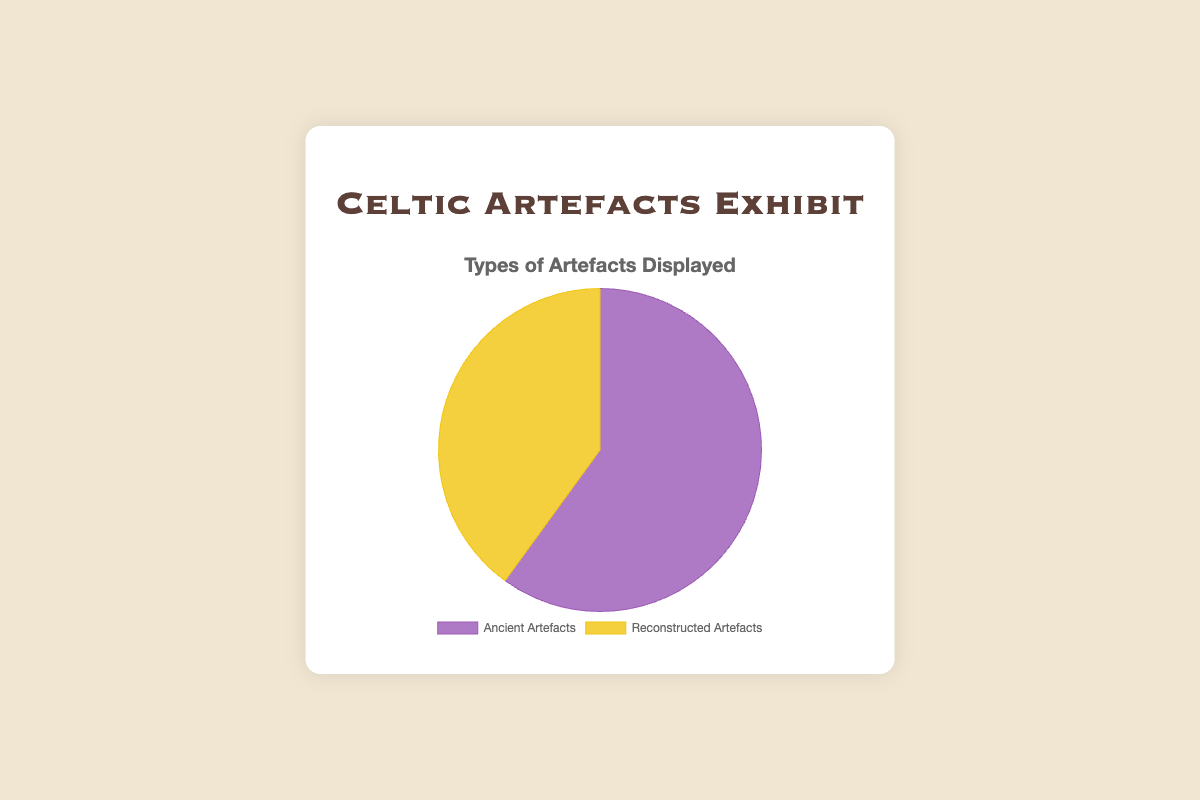What percentage of artefacts on display are ancient? To find the percentage of ancient artefacts, divide the number of ancient artefacts (60) by the total number of artefacts (60 + 40 = 100), then multiply by 100. (60/100) * 100 = 60%.
Answer: 60% Which type of artefact is more prevalent in the exhibit? Comparing the numbers, there are 60 ancient and 40 reconstructed artefacts. Since 60 is greater than 40, ancient artefacts are more prevalent.
Answer: Ancient artefacts How much fewer reconstructed artefacts are there compared to ancient artefacts? Subtract the number of reconstructed artefacts (40) from the number of ancient artefacts (60). 60 - 40 = 20.
Answer: 20 Which section has the smaller slice in the pie chart? Visually, the slice representing reconstructed artefacts is smaller compared to the ancient artefacts slice.
Answer: Reconstructed artefacts If the exhibit added 20 more reconstructed artefacts, how would the percentages change? The new totals would be 60 ancient and 60 reconstructed. Each would now be 50% of the total. (60/120) * 100 = 50%.
Answer: 50% each What is the ratio of ancient to reconstructed artefacts? Divide the number of ancient artefacts (60) by the number of reconstructed artefacts (40). 60/40 simplifies to 3/2.
Answer: 3:2 What fraction of the artefacts are reconstructed? The number of reconstructed artefacts is 40 out of a total of 100 artefacts. The fraction is 40/100, which simplifies to 2/5.
Answer: 2/5 How many more ancient artefacts do we have compared to half the total artefacts in the exhibit? Half of the total artefacts is 100/2 = 50. Ancient artefacts are 60, so 60 - 50 = 10. There are 10 more ancient artefacts compared to half of the total.
Answer: 10 If the exhibit decided to display an equal number of ancient and reconstructed artefacts, how many reconstructed artefacts would need to be added? Currently, there are 60 ancient artefacts and 40 reconstructed. To make them equal, we need to add enough reconstructed artefacts to match 60. So, 60 - 40 = 20 artefacts need to be added.
Answer: 20 